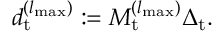Convert formula to latex. <formula><loc_0><loc_0><loc_500><loc_500>\begin{array} { r } { d _ { t } ^ { ( { l _ { \max } } ) } \colon = M _ { t } ^ { ( { l _ { \max } } ) } \Delta _ { t } . } \end{array}</formula> 